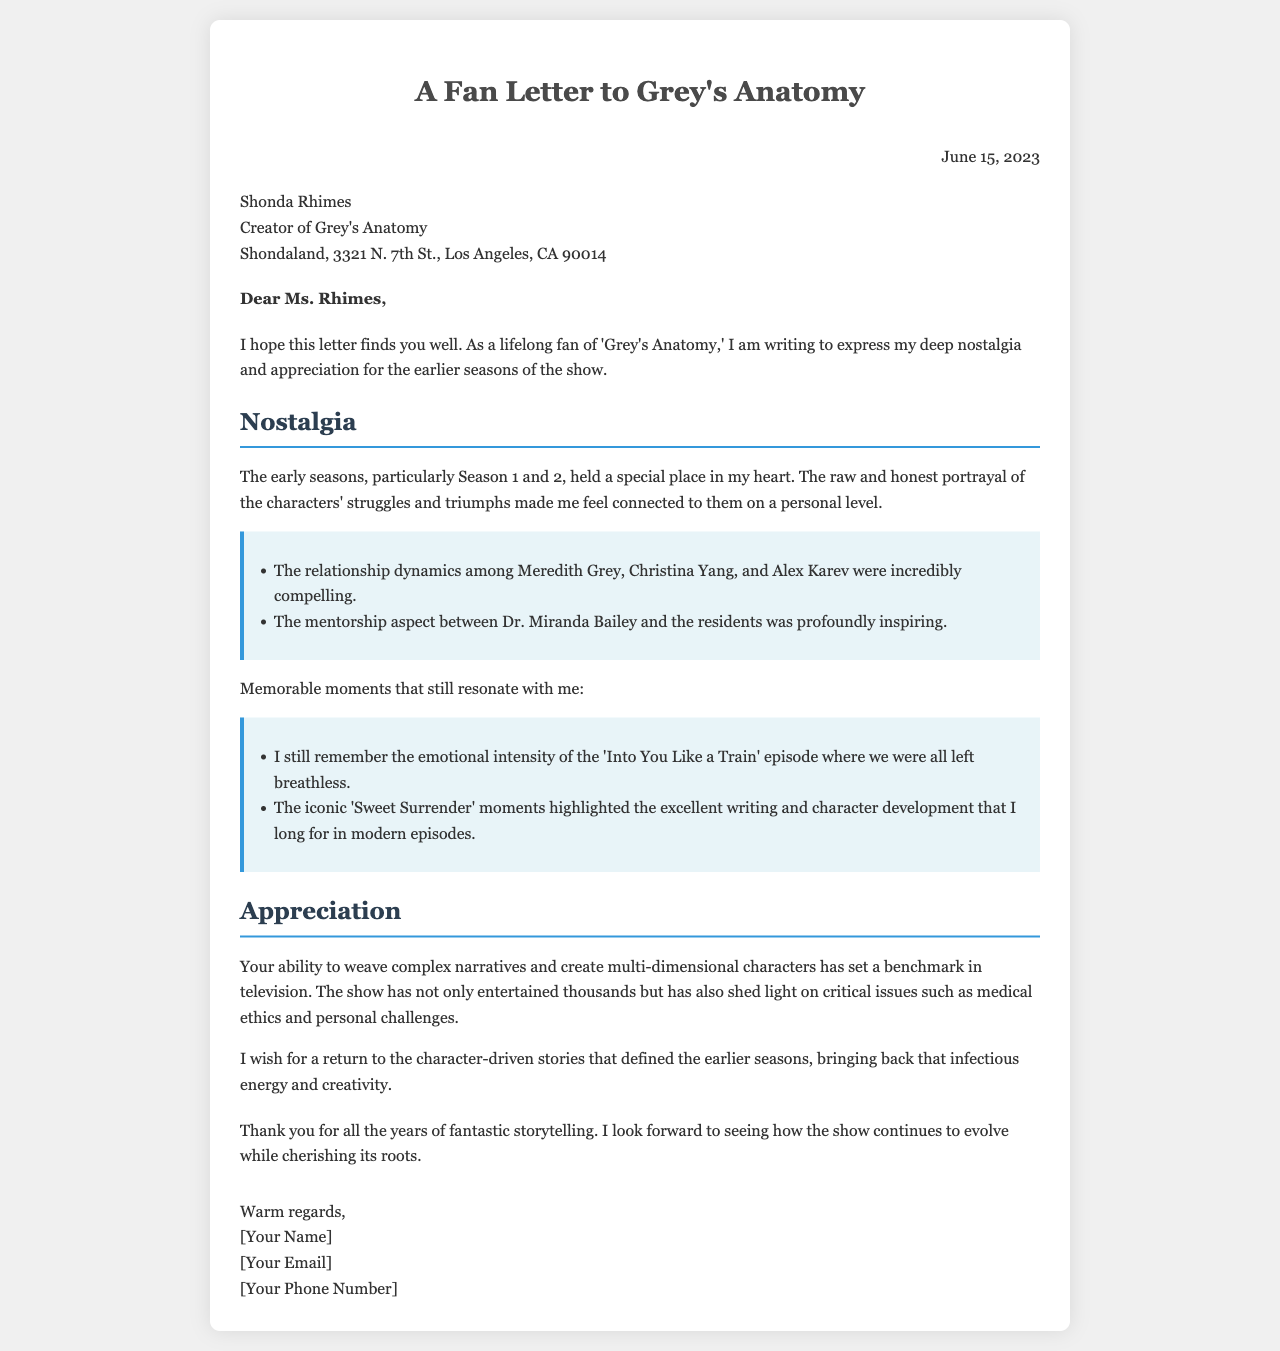what is the date of the letter? The date is provided in the document, indicating when the letter was written.
Answer: June 15, 2023 who is the recipient of the letter? The document specifies the name of the person the letter is addressed to.
Answer: Shonda Rhimes which seasons of 'Grey's Anatomy' are highlighted in terms of nostalgia? The document mentions specific seasons that the author feels nostalgic about.
Answer: Season 1 and 2 what is one memorable episode mentioned in the letter? The letter cites specific episodes that resonated with the author.
Answer: Into You Like a Train what does the author request to return in the show? The document expresses a desire for a particular type of storytelling in the series.
Answer: character-driven stories what is an example of a relationship highlighted in the letter? The letter refers to the dynamics between specific characters.
Answer: Meredith Grey, Christina Yang, and Alex Karev how does the author describe the storytelling in the earlier seasons? The author provides a qualitative assessment of the storytelling aspect of the show earlier.
Answer: complex narratives what feeling does the author convey toward the creator at the end of the letter? The conclusion of the letter reflects a specific sentiment towards the creator's work.
Answer: appreciation 